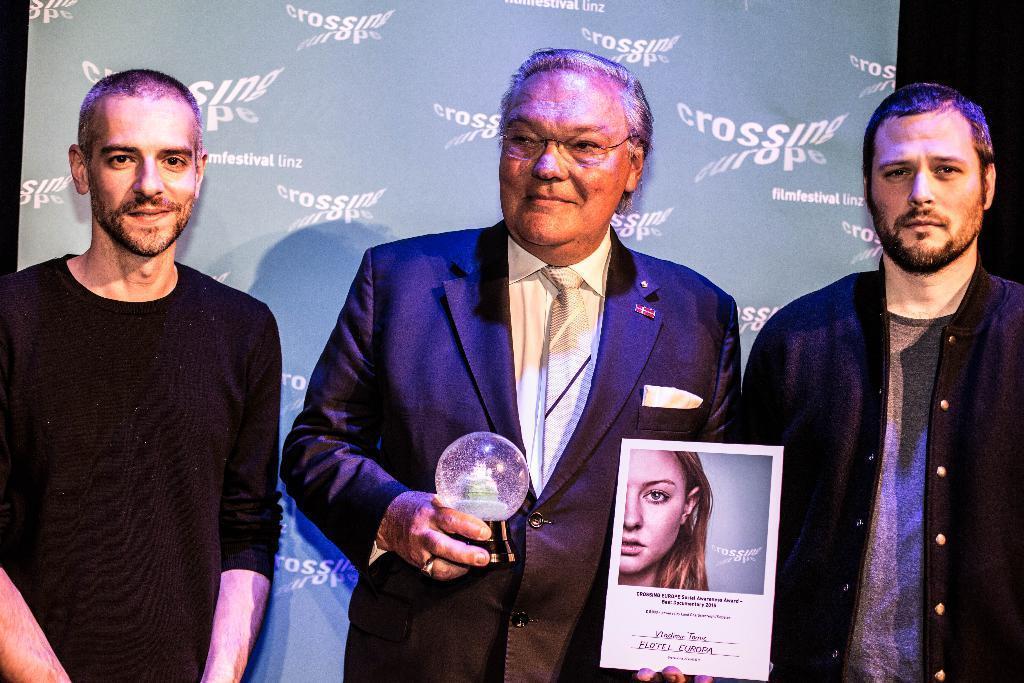Can you describe this image briefly? In this picture we can see three men, the middle man is holding a poster and an object in his hands, behind him we can see a hoarding. 